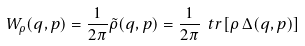<formula> <loc_0><loc_0><loc_500><loc_500>W _ { \rho } ( q , p ) = \frac { 1 } { 2 \pi } \tilde { \rho } ( q , p ) = \frac { 1 } { 2 \pi } \ t r [ \rho \, \Delta ( q , p ) ]</formula> 